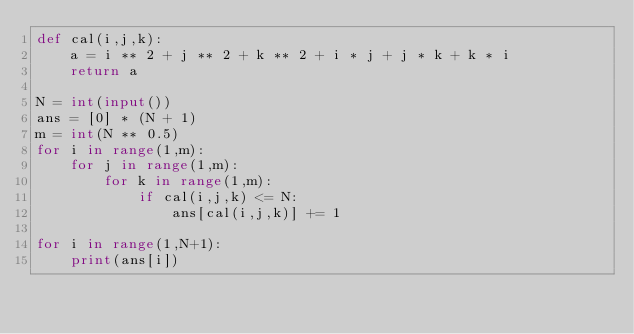<code> <loc_0><loc_0><loc_500><loc_500><_Python_>def cal(i,j,k):
    a = i ** 2 + j ** 2 + k ** 2 + i * j + j * k + k * i 
    return a

N = int(input())
ans = [0] * (N + 1)
m = int(N ** 0.5)
for i in range(1,m):
    for j in range(1,m):
        for k in range(1,m):
            if cal(i,j,k) <= N:
                ans[cal(i,j,k)] += 1

for i in range(1,N+1):
    print(ans[i])</code> 